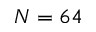<formula> <loc_0><loc_0><loc_500><loc_500>N = 6 4</formula> 